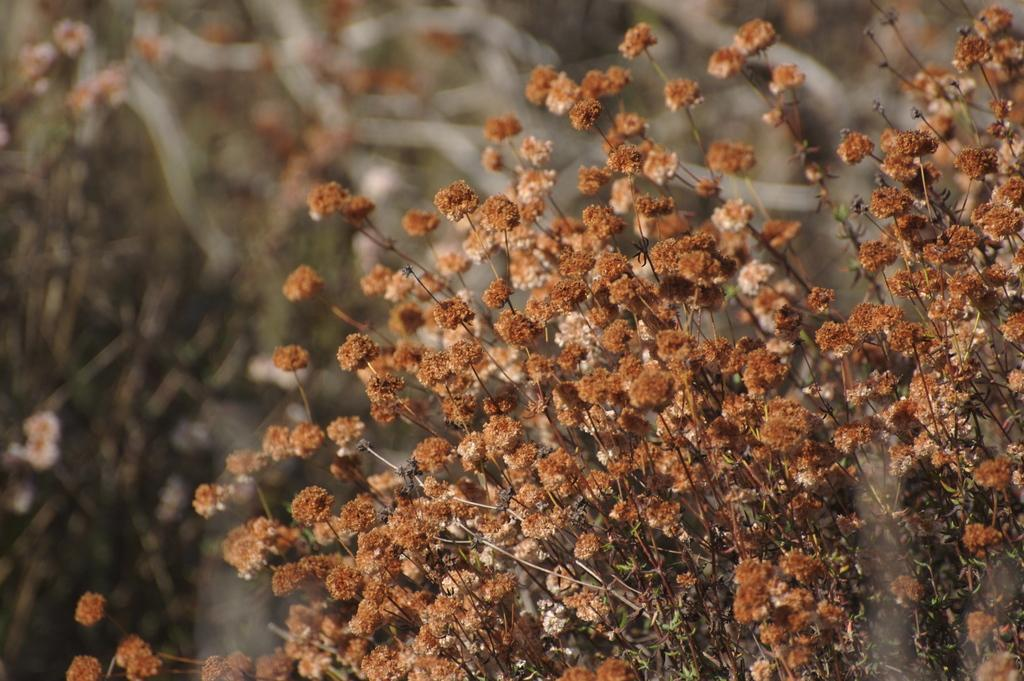What type of plants are visible on the right side of the image? There are plants with flowers on the right side of the image. Can you describe the background of the image? The background of the image is blurred. What division of history is being taught in the image? There is no indication of a class or history lesson in the image. 